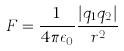Convert formula to latex. <formula><loc_0><loc_0><loc_500><loc_500>F = \frac { 1 } { 4 \pi \epsilon _ { 0 } } \frac { | q _ { 1 } q _ { 2 } | } { r ^ { 2 } }</formula> 